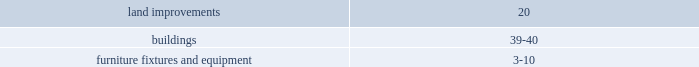The contractual maturities of held-to-maturity securities as of january 30 , 2009 were in excess of three years and were $ 31.4 million at cost and $ 28.9 million at fair value , respectively .
For the successor year ended january 30 , 2009 and period ended february 1 , 2008 , and the predecessor period ended july 6 , 2007 and year ended february 2 , 2007 , gross realized gains and losses on the sales of available-for-sale securities were not material .
The cost of securities sold is based upon the specific identification method .
Merchandise inventories inventories are stated at the lower of cost or market with cost determined using the retail last-in , first-out ( 201clifo 201d ) method .
Under the company 2019s retail inventory method ( 201crim 201d ) , the calculation of gross profit and the resulting valuation of inventories at cost are computed by applying a calculated cost-to-retail inventory ratio to the retail value of sales at a department level .
Costs directly associated with warehousing and distribution are capitalized into inventory .
The excess of current cost over lifo cost was approximately $ 50.0 million at january 30 , 2009 and $ 6.1 million at february 1 , 2008 .
Current cost is determined using the retail first-in , first-out method .
The company 2019s lifo reserves were adjusted to zero at july 6 , 2007 as a result of the merger .
The successor recorded lifo provisions of $ 43.9 million and $ 6.1 million during 2008 and 2007 , respectively .
The predecessor recorded a lifo credit of $ 1.5 million in 2006 .
In 2008 , the increased commodity cost pressures mainly related to food and pet products which have been driven by fruit and vegetable prices and rising freight costs .
Increases in petroleum , resin , metals , pulp and other raw material commodity driven costs also resulted in multiple product cost increases .
The company intends to address these commodity cost increases through negotiations with its vendors and by increasing retail prices as necessary .
On a quarterly basis , the company estimates the annual impact of commodity cost fluctuations based upon the best available information at that point in time .
Store pre-opening costs pre-opening costs related to new store openings and the construction periods are expensed as incurred .
Property and equipment property and equipment are recorded at cost .
The company provides for depreciation and amortization on a straight-line basis over the following estimated useful lives: .
Improvements of leased properties are amortized over the shorter of the life of the applicable lease term or the estimated useful life of the asset. .
What is the percentage change in held-to-maturity securities at cost and at fair value as of january 30 , 2009? 
Computations: ((28.9 - 31.4) / 31.4)
Answer: -0.07962. Consolidated 2005 results of operations was an estimated reduction of gross profit and a corresponding decrease to inventory , at cost , of $ 5.2 million .
Store pre-opening costs pre-opening costs related to new store openings and the construction periods are expensed as incurred .
Property and equipment property and equipment are recorded at cost .
The company provides for depreciation and amortization on a straight-line basis over the following estimated useful lives: .
Improvements of leased properties are amortized over the shorter of the life of the applicable lease term or the estimated useful life of the asset .
Impairment of long-lived assets when indicators of impairment are present , the company evaluates the carrying value of long-lived assets , other than goodwill , in relation to the operating performance and future cash flows or the appraised values of the underlying assets .
In accordance with sfas 144 , 201caccounting for the impairment or disposal of long-lived assets , 201d the company reviews for impairment stores open more than two years for which current cash flows from operations are negative .
Impairment results when the carrying value of the assets exceeds the undiscounted future cash flows over the life of the lease .
The company 2019s estimate of undiscounted future cash flows over the lease term is based upon historical operations of the stores and estimates of future store profitability which encompasses many factors that are subject to variability and difficult to predict .
If a long-lived asset is found to be impaired , the amount recognized for impairment is equal to the difference between the carrying value and the asset 2019s fair value .
The fair value is estimated based primarily upon future cash flows ( discounted at the company 2019s credit adjusted risk-free rate ) or other reasonable estimates of fair market value .
Assets to be disposed of are adjusted to the fair value less the cost to sell if less than the book value .
The company recorded impairment charges , included in sg&a expense , of approximately $ 9.4 million in 2006 , $ 0.6 million in 2005 and $ 0.2 million in 2004 to reduce the carrying value of certain of its stores 2019 assets as deemed necessary due to negative sales trends and cash flows at these locations .
The majority of the 2006 charges were recorded pursuant to certain strategic initiatives discussed in note 2 .
Other assets other assets consist primarily of long-term investments , qualifying prepaid expenses , debt issuance costs which are amortized over the life of the related obligations , utility and security deposits , life insurance policies and goodwill. .
What is the total impairment charge recorded in the lat three years , in millions? 
Computations: ((9.4 + 0.6) + 0.2)
Answer: 10.2. Consolidated 2005 results of operations was an estimated reduction of gross profit and a corresponding decrease to inventory , at cost , of $ 5.2 million .
Store pre-opening costs pre-opening costs related to new store openings and the construction periods are expensed as incurred .
Property and equipment property and equipment are recorded at cost .
The company provides for depreciation and amortization on a straight-line basis over the following estimated useful lives: .
Improvements of leased properties are amortized over the shorter of the life of the applicable lease term or the estimated useful life of the asset .
Impairment of long-lived assets when indicators of impairment are present , the company evaluates the carrying value of long-lived assets , other than goodwill , in relation to the operating performance and future cash flows or the appraised values of the underlying assets .
In accordance with sfas 144 , 201caccounting for the impairment or disposal of long-lived assets , 201d the company reviews for impairment stores open more than two years for which current cash flows from operations are negative .
Impairment results when the carrying value of the assets exceeds the undiscounted future cash flows over the life of the lease .
The company 2019s estimate of undiscounted future cash flows over the lease term is based upon historical operations of the stores and estimates of future store profitability which encompasses many factors that are subject to variability and difficult to predict .
If a long-lived asset is found to be impaired , the amount recognized for impairment is equal to the difference between the carrying value and the asset 2019s fair value .
The fair value is estimated based primarily upon future cash flows ( discounted at the company 2019s credit adjusted risk-free rate ) or other reasonable estimates of fair market value .
Assets to be disposed of are adjusted to the fair value less the cost to sell if less than the book value .
The company recorded impairment charges , included in sg&a expense , of approximately $ 9.4 million in 2006 , $ 0.6 million in 2005 and $ 0.2 million in 2004 to reduce the carrying value of certain of its stores 2019 assets as deemed necessary due to negative sales trends and cash flows at these locations .
The majority of the 2006 charges were recorded pursuant to certain strategic initiatives discussed in note 2 .
Other assets other assets consist primarily of long-term investments , qualifying prepaid expenses , debt issuance costs which are amortized over the life of the related obligations , utility and security deposits , life insurance policies and goodwill. .
What is the yearly depreciation rate on land improvements? 
Computations: (100 / 20)
Answer: 5.0. The contractual maturities of held-to-maturity securities as of january 30 , 2009 were in excess of three years and were $ 31.4 million at cost and $ 28.9 million at fair value , respectively .
For the successor year ended january 30 , 2009 and period ended february 1 , 2008 , and the predecessor period ended july 6 , 2007 and year ended february 2 , 2007 , gross realized gains and losses on the sales of available-for-sale securities were not material .
The cost of securities sold is based upon the specific identification method .
Merchandise inventories inventories are stated at the lower of cost or market with cost determined using the retail last-in , first-out ( 201clifo 201d ) method .
Under the company 2019s retail inventory method ( 201crim 201d ) , the calculation of gross profit and the resulting valuation of inventories at cost are computed by applying a calculated cost-to-retail inventory ratio to the retail value of sales at a department level .
Costs directly associated with warehousing and distribution are capitalized into inventory .
The excess of current cost over lifo cost was approximately $ 50.0 million at january 30 , 2009 and $ 6.1 million at february 1 , 2008 .
Current cost is determined using the retail first-in , first-out method .
The company 2019s lifo reserves were adjusted to zero at july 6 , 2007 as a result of the merger .
The successor recorded lifo provisions of $ 43.9 million and $ 6.1 million during 2008 and 2007 , respectively .
The predecessor recorded a lifo credit of $ 1.5 million in 2006 .
In 2008 , the increased commodity cost pressures mainly related to food and pet products which have been driven by fruit and vegetable prices and rising freight costs .
Increases in petroleum , resin , metals , pulp and other raw material commodity driven costs also resulted in multiple product cost increases .
The company intends to address these commodity cost increases through negotiations with its vendors and by increasing retail prices as necessary .
On a quarterly basis , the company estimates the annual impact of commodity cost fluctuations based upon the best available information at that point in time .
Store pre-opening costs pre-opening costs related to new store openings and the construction periods are expensed as incurred .
Property and equipment property and equipment are recorded at cost .
The company provides for depreciation and amortization on a straight-line basis over the following estimated useful lives: .
Improvements of leased properties are amortized over the shorter of the life of the applicable lease term or the estimated useful life of the asset. .
What the difference of the held-to-maturity securities at cost and at fair value as of january 30 , 2009 , in millions? 
Computations: (31.4 - 28.9)
Answer: 2.5. 